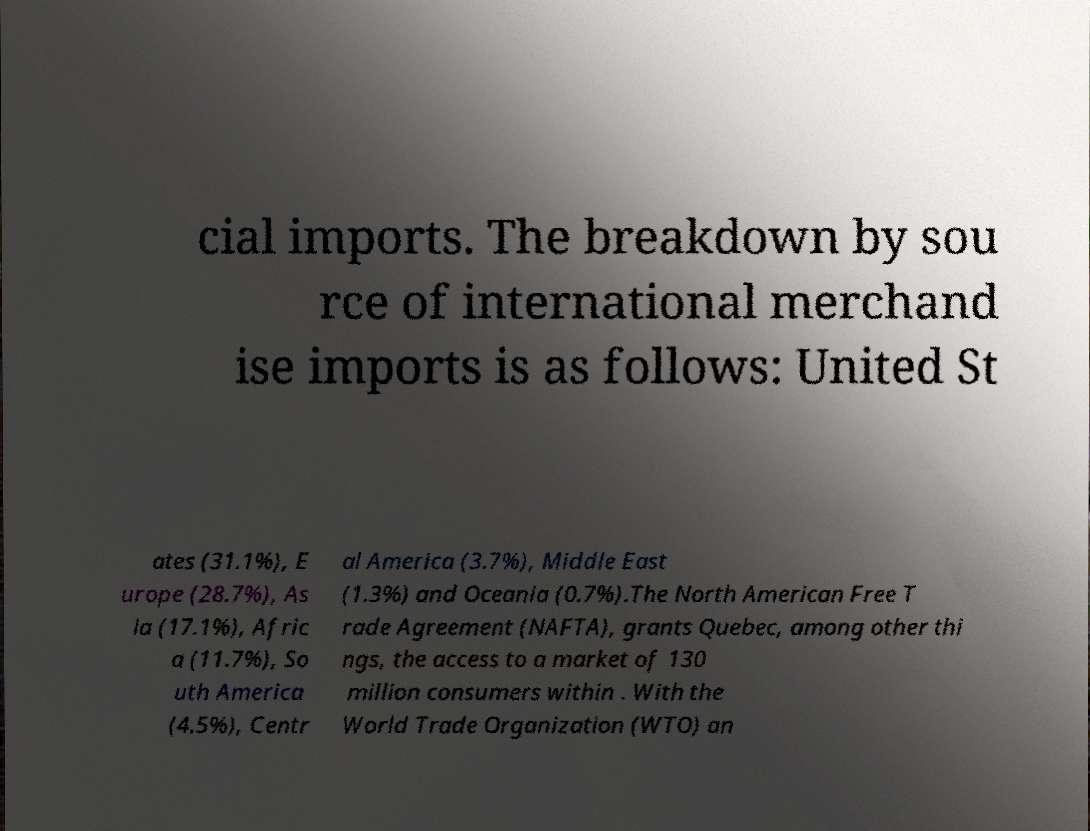Could you extract and type out the text from this image? cial imports. The breakdown by sou rce of international merchand ise imports is as follows: United St ates (31.1%), E urope (28.7%), As ia (17.1%), Afric a (11.7%), So uth America (4.5%), Centr al America (3.7%), Middle East (1.3%) and Oceania (0.7%).The North American Free T rade Agreement (NAFTA), grants Quebec, among other thi ngs, the access to a market of 130 million consumers within . With the World Trade Organization (WTO) an 